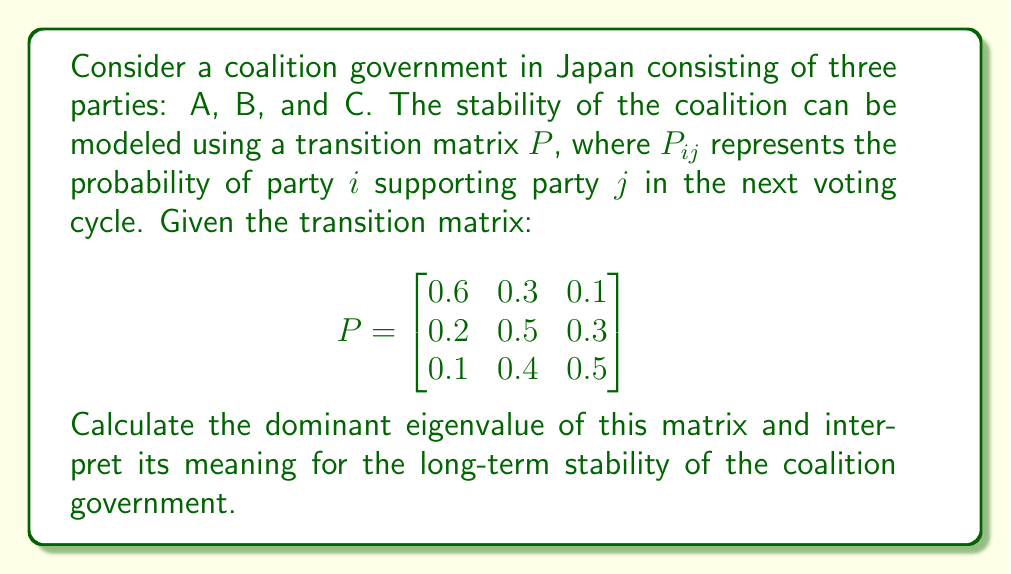Can you solve this math problem? To analyze the stability of the coalition government using the given transition matrix, we need to find its eigenvalues and eigenvectors. The dominant eigenvalue will provide insights into the long-term behavior of the system.

Step 1: Find the characteristic equation of the matrix P.
$$\det(P - \lambda I) = 0$$
$$\begin{vmatrix}
0.6-\lambda & 0.3 & 0.1 \\
0.2 & 0.5-\lambda & 0.3 \\
0.1 & 0.4 & 0.5-\lambda
\end{vmatrix} = 0$$

Step 2: Expand the determinant.
$$(0.6-\lambda)[(0.5-\lambda)(0.5-\lambda)-0.12] - 0.3[0.2(0.5-\lambda)-0.03] + 0.1[0.08-0.2(0.5-\lambda)] = 0$$

Step 3: Simplify the equation.
$$-\lambda^3 + 1.6\lambda^2 - 0.71\lambda + 0.09 = 0$$

Step 4: Solve the characteristic equation. The eigenvalues are approximately:
$$\lambda_1 \approx 1, \lambda_2 \approx 0.37, \lambda_3 \approx 0.23$$

Step 5: Identify the dominant eigenvalue.
The dominant eigenvalue is $\lambda_1 \approx 1$.

Step 6: Interpret the result.
In Markov chain theory, when the dominant eigenvalue is 1, it indicates that the system has a unique stationary distribution. This means that in the long run, the coalition will reach a stable equilibrium where the proportions of support for each party remain constant.

The fact that the dominant eigenvalue is very close to 1 (and not exactly 1 due to rounding) suggests that the coalition is likely to be stable in the long term, as the system will converge to a steady state.
Answer: Dominant eigenvalue ≈ 1, indicating long-term stability of the coalition government. 